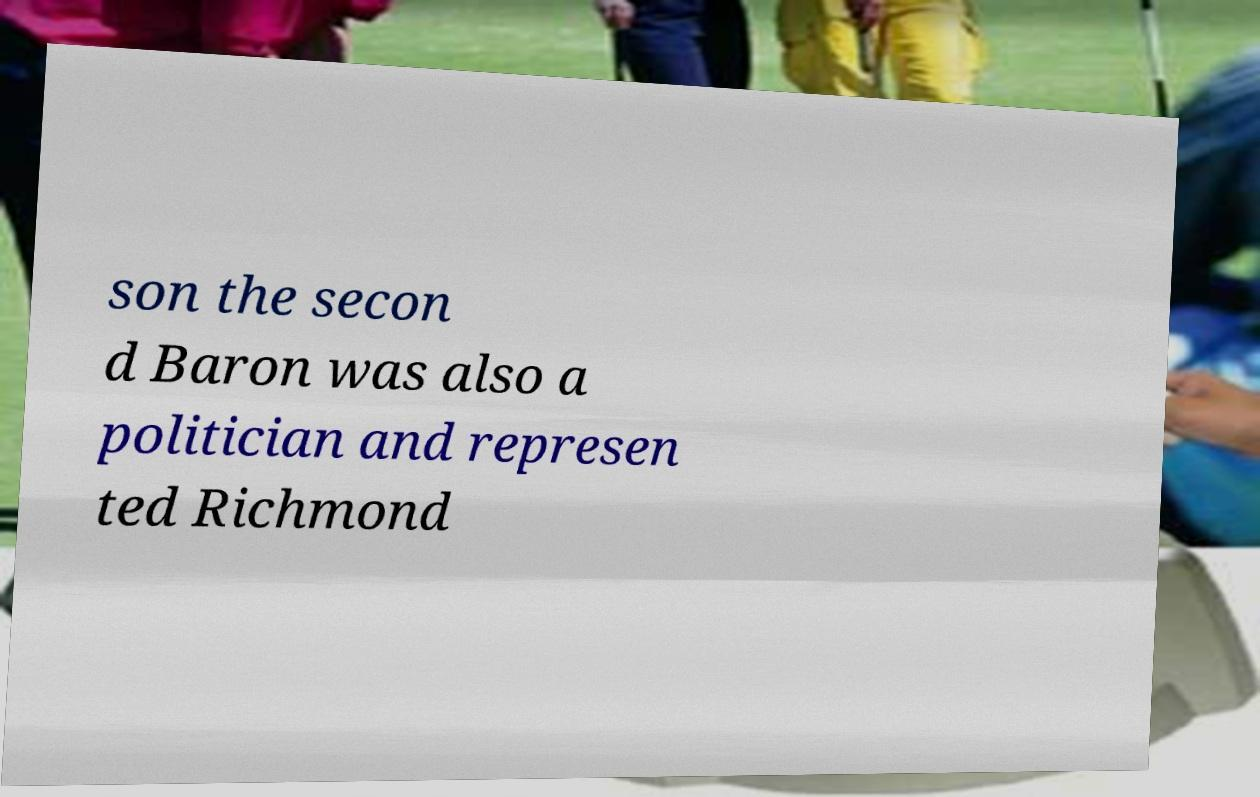Could you extract and type out the text from this image? son the secon d Baron was also a politician and represen ted Richmond 